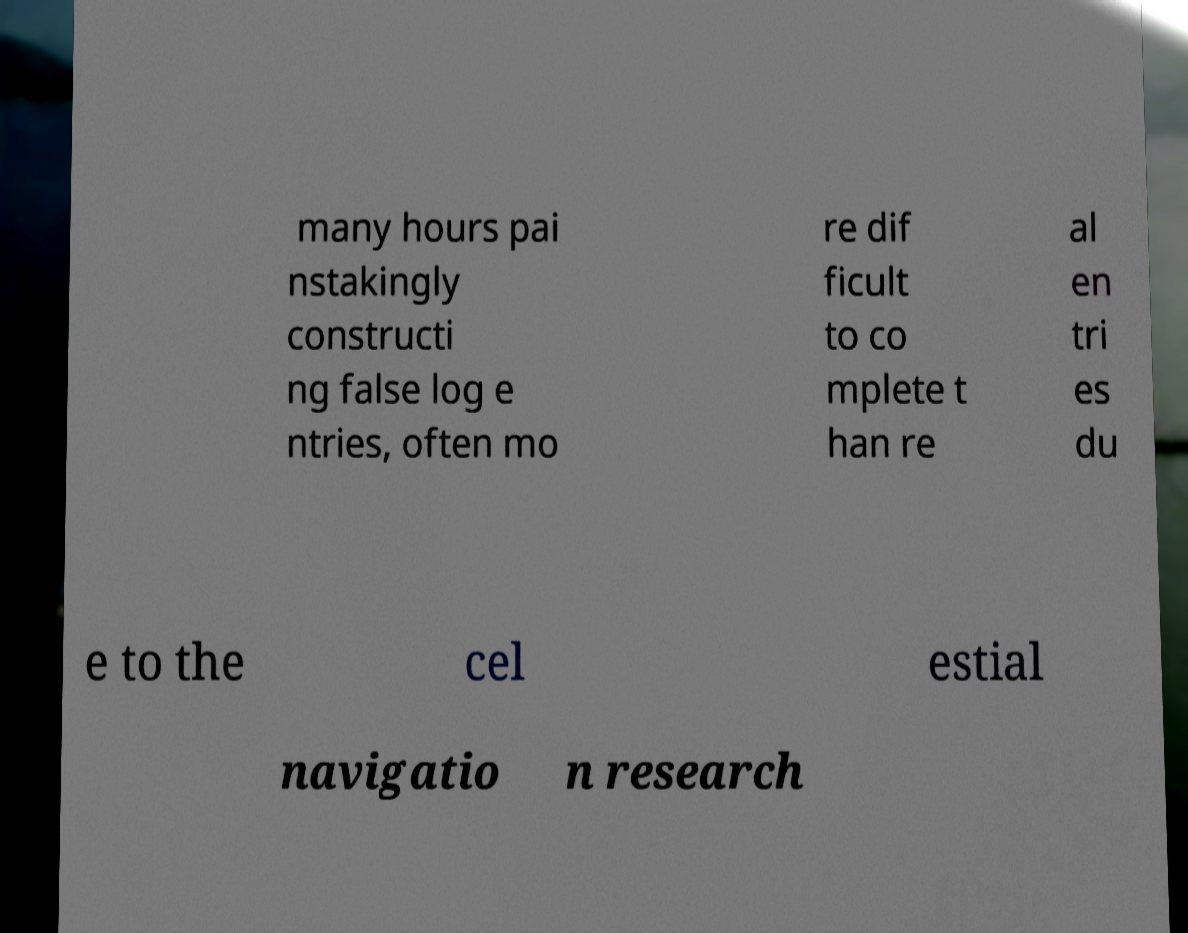What messages or text are displayed in this image? I need them in a readable, typed format. many hours pai nstakingly constructi ng false log e ntries, often mo re dif ficult to co mplete t han re al en tri es du e to the cel estial navigatio n research 